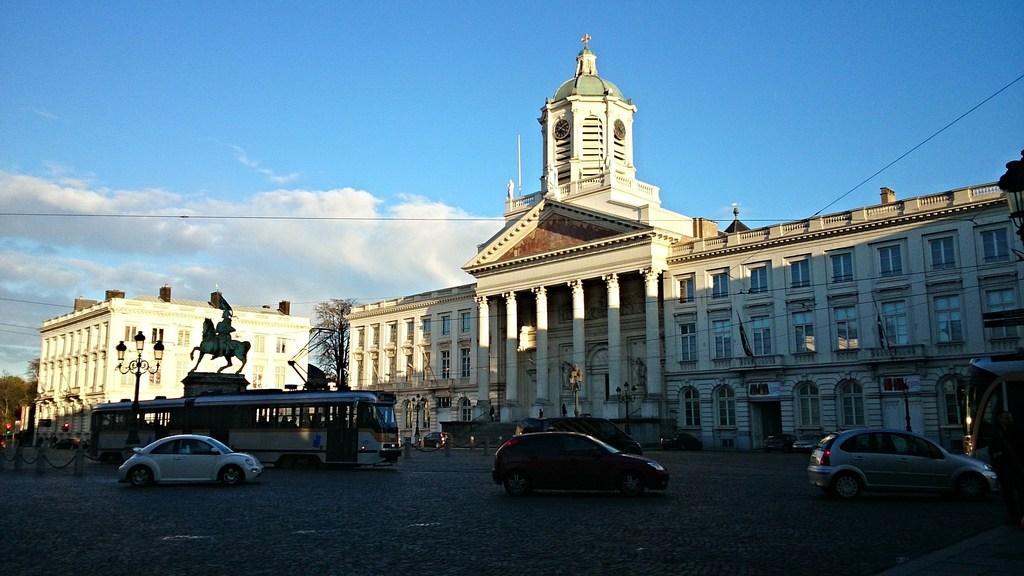How would you summarize this image in a sentence or two? In this picture I can see vehicles on the road. Here I can see street lights, trees and wires. In the background I can see buildings and the sky. 